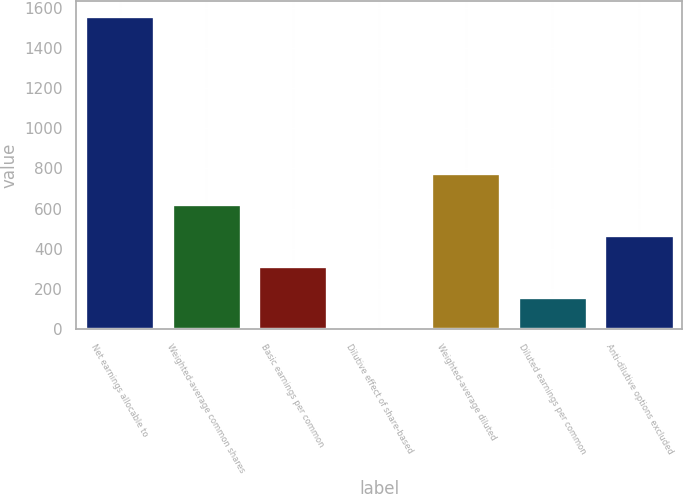Convert chart. <chart><loc_0><loc_0><loc_500><loc_500><bar_chart><fcel>Net earnings allocable to<fcel>Weighted-average common shares<fcel>Basic earnings per common<fcel>Dilutive effect of share-based<fcel>Weighted-average diluted<fcel>Diluted earnings per common<fcel>Anti-dilutive options excluded<nl><fcel>1558<fcel>624.4<fcel>313.2<fcel>2<fcel>780<fcel>157.6<fcel>468.8<nl></chart> 